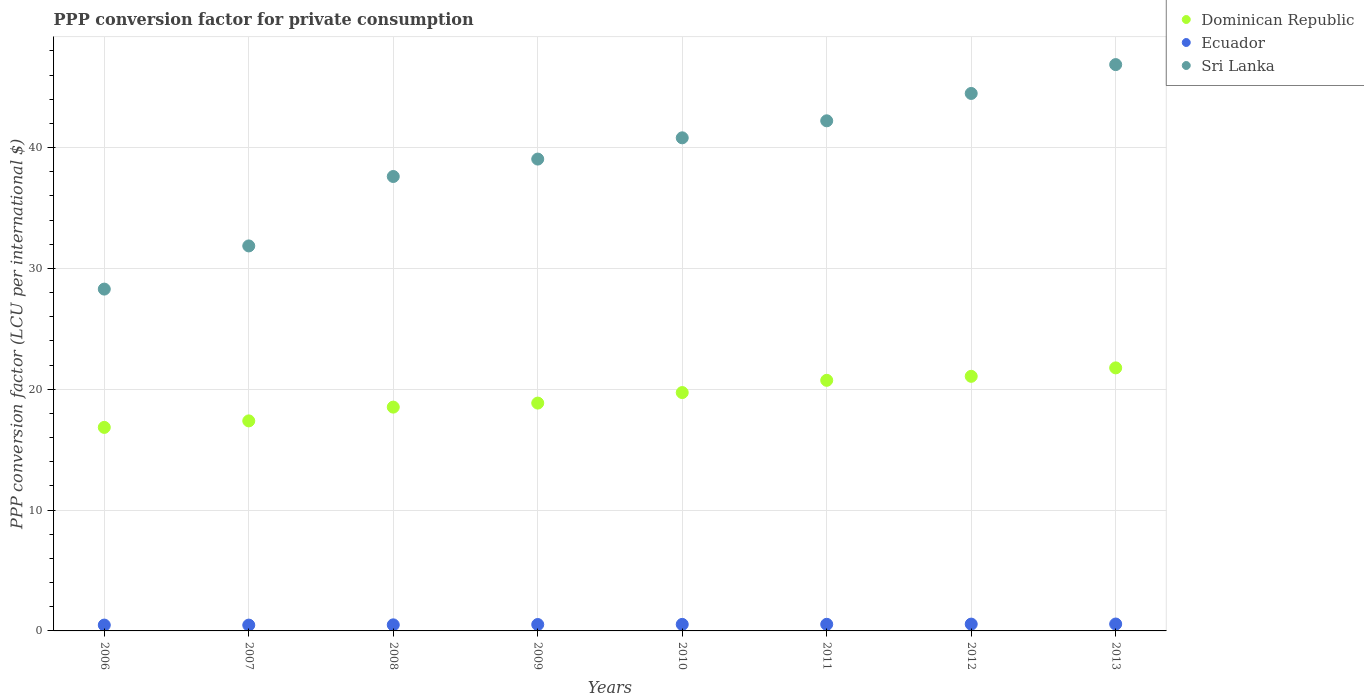How many different coloured dotlines are there?
Offer a terse response. 3. What is the PPP conversion factor for private consumption in Sri Lanka in 2013?
Your answer should be compact. 46.87. Across all years, what is the maximum PPP conversion factor for private consumption in Ecuador?
Make the answer very short. 0.57. Across all years, what is the minimum PPP conversion factor for private consumption in Ecuador?
Give a very brief answer. 0.48. In which year was the PPP conversion factor for private consumption in Sri Lanka maximum?
Your answer should be very brief. 2013. What is the total PPP conversion factor for private consumption in Ecuador in the graph?
Keep it short and to the point. 4.22. What is the difference between the PPP conversion factor for private consumption in Sri Lanka in 2006 and that in 2010?
Give a very brief answer. -12.52. What is the difference between the PPP conversion factor for private consumption in Dominican Republic in 2011 and the PPP conversion factor for private consumption in Sri Lanka in 2013?
Offer a very short reply. -26.13. What is the average PPP conversion factor for private consumption in Ecuador per year?
Keep it short and to the point. 0.53. In the year 2009, what is the difference between the PPP conversion factor for private consumption in Dominican Republic and PPP conversion factor for private consumption in Sri Lanka?
Keep it short and to the point. -20.2. In how many years, is the PPP conversion factor for private consumption in Dominican Republic greater than 32 LCU?
Your answer should be compact. 0. What is the ratio of the PPP conversion factor for private consumption in Sri Lanka in 2008 to that in 2012?
Ensure brevity in your answer.  0.85. Is the PPP conversion factor for private consumption in Dominican Republic in 2011 less than that in 2012?
Provide a succinct answer. Yes. What is the difference between the highest and the second highest PPP conversion factor for private consumption in Sri Lanka?
Your answer should be compact. 2.39. What is the difference between the highest and the lowest PPP conversion factor for private consumption in Sri Lanka?
Ensure brevity in your answer.  18.58. Does the PPP conversion factor for private consumption in Ecuador monotonically increase over the years?
Your response must be concise. No. What is the difference between two consecutive major ticks on the Y-axis?
Your answer should be very brief. 10. Are the values on the major ticks of Y-axis written in scientific E-notation?
Provide a succinct answer. No. Does the graph contain any zero values?
Make the answer very short. No. Where does the legend appear in the graph?
Ensure brevity in your answer.  Top right. How are the legend labels stacked?
Provide a short and direct response. Vertical. What is the title of the graph?
Your response must be concise. PPP conversion factor for private consumption. Does "Low & middle income" appear as one of the legend labels in the graph?
Offer a very short reply. No. What is the label or title of the X-axis?
Make the answer very short. Years. What is the label or title of the Y-axis?
Ensure brevity in your answer.  PPP conversion factor (LCU per international $). What is the PPP conversion factor (LCU per international $) in Dominican Republic in 2006?
Your answer should be compact. 16.84. What is the PPP conversion factor (LCU per international $) of Ecuador in 2006?
Give a very brief answer. 0.48. What is the PPP conversion factor (LCU per international $) of Sri Lanka in 2006?
Give a very brief answer. 28.29. What is the PPP conversion factor (LCU per international $) in Dominican Republic in 2007?
Offer a very short reply. 17.38. What is the PPP conversion factor (LCU per international $) of Ecuador in 2007?
Offer a very short reply. 0.48. What is the PPP conversion factor (LCU per international $) in Sri Lanka in 2007?
Provide a succinct answer. 31.86. What is the PPP conversion factor (LCU per international $) in Dominican Republic in 2008?
Make the answer very short. 18.52. What is the PPP conversion factor (LCU per international $) of Ecuador in 2008?
Offer a very short reply. 0.5. What is the PPP conversion factor (LCU per international $) in Sri Lanka in 2008?
Offer a very short reply. 37.61. What is the PPP conversion factor (LCU per international $) of Dominican Republic in 2009?
Your answer should be very brief. 18.86. What is the PPP conversion factor (LCU per international $) in Ecuador in 2009?
Keep it short and to the point. 0.53. What is the PPP conversion factor (LCU per international $) in Sri Lanka in 2009?
Your response must be concise. 39.05. What is the PPP conversion factor (LCU per international $) of Dominican Republic in 2010?
Your response must be concise. 19.73. What is the PPP conversion factor (LCU per international $) of Ecuador in 2010?
Your answer should be very brief. 0.54. What is the PPP conversion factor (LCU per international $) in Sri Lanka in 2010?
Provide a short and direct response. 40.81. What is the PPP conversion factor (LCU per international $) of Dominican Republic in 2011?
Keep it short and to the point. 20.74. What is the PPP conversion factor (LCU per international $) of Ecuador in 2011?
Give a very brief answer. 0.55. What is the PPP conversion factor (LCU per international $) of Sri Lanka in 2011?
Offer a very short reply. 42.22. What is the PPP conversion factor (LCU per international $) in Dominican Republic in 2012?
Give a very brief answer. 21.07. What is the PPP conversion factor (LCU per international $) in Ecuador in 2012?
Your response must be concise. 0.56. What is the PPP conversion factor (LCU per international $) of Sri Lanka in 2012?
Ensure brevity in your answer.  44.48. What is the PPP conversion factor (LCU per international $) of Dominican Republic in 2013?
Provide a succinct answer. 21.77. What is the PPP conversion factor (LCU per international $) in Ecuador in 2013?
Your answer should be very brief. 0.57. What is the PPP conversion factor (LCU per international $) of Sri Lanka in 2013?
Keep it short and to the point. 46.87. Across all years, what is the maximum PPP conversion factor (LCU per international $) in Dominican Republic?
Your answer should be very brief. 21.77. Across all years, what is the maximum PPP conversion factor (LCU per international $) of Ecuador?
Give a very brief answer. 0.57. Across all years, what is the maximum PPP conversion factor (LCU per international $) of Sri Lanka?
Ensure brevity in your answer.  46.87. Across all years, what is the minimum PPP conversion factor (LCU per international $) of Dominican Republic?
Offer a terse response. 16.84. Across all years, what is the minimum PPP conversion factor (LCU per international $) in Ecuador?
Offer a terse response. 0.48. Across all years, what is the minimum PPP conversion factor (LCU per international $) in Sri Lanka?
Give a very brief answer. 28.29. What is the total PPP conversion factor (LCU per international $) of Dominican Republic in the graph?
Provide a short and direct response. 154.92. What is the total PPP conversion factor (LCU per international $) in Ecuador in the graph?
Your answer should be very brief. 4.22. What is the total PPP conversion factor (LCU per international $) of Sri Lanka in the graph?
Your response must be concise. 311.2. What is the difference between the PPP conversion factor (LCU per international $) of Dominican Republic in 2006 and that in 2007?
Provide a succinct answer. -0.54. What is the difference between the PPP conversion factor (LCU per international $) in Ecuador in 2006 and that in 2007?
Provide a short and direct response. 0. What is the difference between the PPP conversion factor (LCU per international $) in Sri Lanka in 2006 and that in 2007?
Your response must be concise. -3.57. What is the difference between the PPP conversion factor (LCU per international $) of Dominican Republic in 2006 and that in 2008?
Offer a very short reply. -1.68. What is the difference between the PPP conversion factor (LCU per international $) of Ecuador in 2006 and that in 2008?
Your answer should be compact. -0.02. What is the difference between the PPP conversion factor (LCU per international $) in Sri Lanka in 2006 and that in 2008?
Keep it short and to the point. -9.32. What is the difference between the PPP conversion factor (LCU per international $) of Dominican Republic in 2006 and that in 2009?
Give a very brief answer. -2.01. What is the difference between the PPP conversion factor (LCU per international $) of Ecuador in 2006 and that in 2009?
Offer a very short reply. -0.05. What is the difference between the PPP conversion factor (LCU per international $) of Sri Lanka in 2006 and that in 2009?
Provide a succinct answer. -10.76. What is the difference between the PPP conversion factor (LCU per international $) of Dominican Republic in 2006 and that in 2010?
Give a very brief answer. -2.88. What is the difference between the PPP conversion factor (LCU per international $) in Ecuador in 2006 and that in 2010?
Your answer should be compact. -0.06. What is the difference between the PPP conversion factor (LCU per international $) of Sri Lanka in 2006 and that in 2010?
Your answer should be very brief. -12.52. What is the difference between the PPP conversion factor (LCU per international $) of Dominican Republic in 2006 and that in 2011?
Make the answer very short. -3.9. What is the difference between the PPP conversion factor (LCU per international $) of Ecuador in 2006 and that in 2011?
Provide a short and direct response. -0.06. What is the difference between the PPP conversion factor (LCU per international $) of Sri Lanka in 2006 and that in 2011?
Your answer should be compact. -13.93. What is the difference between the PPP conversion factor (LCU per international $) in Dominican Republic in 2006 and that in 2012?
Provide a short and direct response. -4.23. What is the difference between the PPP conversion factor (LCU per international $) in Ecuador in 2006 and that in 2012?
Provide a short and direct response. -0.08. What is the difference between the PPP conversion factor (LCU per international $) in Sri Lanka in 2006 and that in 2012?
Ensure brevity in your answer.  -16.19. What is the difference between the PPP conversion factor (LCU per international $) in Dominican Republic in 2006 and that in 2013?
Offer a very short reply. -4.93. What is the difference between the PPP conversion factor (LCU per international $) of Ecuador in 2006 and that in 2013?
Offer a very short reply. -0.09. What is the difference between the PPP conversion factor (LCU per international $) of Sri Lanka in 2006 and that in 2013?
Your response must be concise. -18.58. What is the difference between the PPP conversion factor (LCU per international $) in Dominican Republic in 2007 and that in 2008?
Give a very brief answer. -1.14. What is the difference between the PPP conversion factor (LCU per international $) of Ecuador in 2007 and that in 2008?
Offer a terse response. -0.02. What is the difference between the PPP conversion factor (LCU per international $) of Sri Lanka in 2007 and that in 2008?
Keep it short and to the point. -5.75. What is the difference between the PPP conversion factor (LCU per international $) of Dominican Republic in 2007 and that in 2009?
Your answer should be very brief. -1.47. What is the difference between the PPP conversion factor (LCU per international $) of Ecuador in 2007 and that in 2009?
Keep it short and to the point. -0.05. What is the difference between the PPP conversion factor (LCU per international $) of Sri Lanka in 2007 and that in 2009?
Your answer should be very brief. -7.19. What is the difference between the PPP conversion factor (LCU per international $) of Dominican Republic in 2007 and that in 2010?
Your answer should be compact. -2.34. What is the difference between the PPP conversion factor (LCU per international $) in Ecuador in 2007 and that in 2010?
Your answer should be compact. -0.06. What is the difference between the PPP conversion factor (LCU per international $) in Sri Lanka in 2007 and that in 2010?
Provide a short and direct response. -8.95. What is the difference between the PPP conversion factor (LCU per international $) in Dominican Republic in 2007 and that in 2011?
Offer a terse response. -3.36. What is the difference between the PPP conversion factor (LCU per international $) of Ecuador in 2007 and that in 2011?
Keep it short and to the point. -0.07. What is the difference between the PPP conversion factor (LCU per international $) in Sri Lanka in 2007 and that in 2011?
Provide a short and direct response. -10.36. What is the difference between the PPP conversion factor (LCU per international $) in Dominican Republic in 2007 and that in 2012?
Make the answer very short. -3.69. What is the difference between the PPP conversion factor (LCU per international $) of Ecuador in 2007 and that in 2012?
Keep it short and to the point. -0.08. What is the difference between the PPP conversion factor (LCU per international $) of Sri Lanka in 2007 and that in 2012?
Your answer should be very brief. -12.62. What is the difference between the PPP conversion factor (LCU per international $) of Dominican Republic in 2007 and that in 2013?
Ensure brevity in your answer.  -4.39. What is the difference between the PPP conversion factor (LCU per international $) in Ecuador in 2007 and that in 2013?
Keep it short and to the point. -0.09. What is the difference between the PPP conversion factor (LCU per international $) in Sri Lanka in 2007 and that in 2013?
Provide a succinct answer. -15.01. What is the difference between the PPP conversion factor (LCU per international $) of Dominican Republic in 2008 and that in 2009?
Your response must be concise. -0.33. What is the difference between the PPP conversion factor (LCU per international $) in Ecuador in 2008 and that in 2009?
Make the answer very short. -0.03. What is the difference between the PPP conversion factor (LCU per international $) of Sri Lanka in 2008 and that in 2009?
Offer a very short reply. -1.44. What is the difference between the PPP conversion factor (LCU per international $) of Dominican Republic in 2008 and that in 2010?
Your response must be concise. -1.2. What is the difference between the PPP conversion factor (LCU per international $) in Ecuador in 2008 and that in 2010?
Provide a short and direct response. -0.04. What is the difference between the PPP conversion factor (LCU per international $) of Sri Lanka in 2008 and that in 2010?
Provide a short and direct response. -3.2. What is the difference between the PPP conversion factor (LCU per international $) in Dominican Republic in 2008 and that in 2011?
Offer a very short reply. -2.22. What is the difference between the PPP conversion factor (LCU per international $) in Ecuador in 2008 and that in 2011?
Your answer should be very brief. -0.04. What is the difference between the PPP conversion factor (LCU per international $) of Sri Lanka in 2008 and that in 2011?
Offer a very short reply. -4.61. What is the difference between the PPP conversion factor (LCU per international $) of Dominican Republic in 2008 and that in 2012?
Provide a succinct answer. -2.55. What is the difference between the PPP conversion factor (LCU per international $) of Ecuador in 2008 and that in 2012?
Provide a succinct answer. -0.06. What is the difference between the PPP conversion factor (LCU per international $) in Sri Lanka in 2008 and that in 2012?
Your answer should be very brief. -6.87. What is the difference between the PPP conversion factor (LCU per international $) of Dominican Republic in 2008 and that in 2013?
Your response must be concise. -3.25. What is the difference between the PPP conversion factor (LCU per international $) in Ecuador in 2008 and that in 2013?
Offer a very short reply. -0.07. What is the difference between the PPP conversion factor (LCU per international $) in Sri Lanka in 2008 and that in 2013?
Your answer should be compact. -9.26. What is the difference between the PPP conversion factor (LCU per international $) of Dominican Republic in 2009 and that in 2010?
Provide a short and direct response. -0.87. What is the difference between the PPP conversion factor (LCU per international $) in Ecuador in 2009 and that in 2010?
Your answer should be compact. -0.01. What is the difference between the PPP conversion factor (LCU per international $) of Sri Lanka in 2009 and that in 2010?
Offer a terse response. -1.76. What is the difference between the PPP conversion factor (LCU per international $) in Dominican Republic in 2009 and that in 2011?
Provide a short and direct response. -1.88. What is the difference between the PPP conversion factor (LCU per international $) of Ecuador in 2009 and that in 2011?
Provide a short and direct response. -0.02. What is the difference between the PPP conversion factor (LCU per international $) of Sri Lanka in 2009 and that in 2011?
Offer a very short reply. -3.17. What is the difference between the PPP conversion factor (LCU per international $) in Dominican Republic in 2009 and that in 2012?
Provide a succinct answer. -2.21. What is the difference between the PPP conversion factor (LCU per international $) in Ecuador in 2009 and that in 2012?
Ensure brevity in your answer.  -0.03. What is the difference between the PPP conversion factor (LCU per international $) of Sri Lanka in 2009 and that in 2012?
Ensure brevity in your answer.  -5.43. What is the difference between the PPP conversion factor (LCU per international $) of Dominican Republic in 2009 and that in 2013?
Keep it short and to the point. -2.91. What is the difference between the PPP conversion factor (LCU per international $) of Ecuador in 2009 and that in 2013?
Keep it short and to the point. -0.04. What is the difference between the PPP conversion factor (LCU per international $) of Sri Lanka in 2009 and that in 2013?
Your answer should be compact. -7.82. What is the difference between the PPP conversion factor (LCU per international $) in Dominican Republic in 2010 and that in 2011?
Ensure brevity in your answer.  -1.01. What is the difference between the PPP conversion factor (LCU per international $) of Ecuador in 2010 and that in 2011?
Provide a short and direct response. -0.01. What is the difference between the PPP conversion factor (LCU per international $) in Sri Lanka in 2010 and that in 2011?
Make the answer very short. -1.41. What is the difference between the PPP conversion factor (LCU per international $) in Dominican Republic in 2010 and that in 2012?
Ensure brevity in your answer.  -1.34. What is the difference between the PPP conversion factor (LCU per international $) of Ecuador in 2010 and that in 2012?
Your answer should be very brief. -0.02. What is the difference between the PPP conversion factor (LCU per international $) of Sri Lanka in 2010 and that in 2012?
Provide a short and direct response. -3.67. What is the difference between the PPP conversion factor (LCU per international $) in Dominican Republic in 2010 and that in 2013?
Provide a succinct answer. -2.04. What is the difference between the PPP conversion factor (LCU per international $) of Ecuador in 2010 and that in 2013?
Your response must be concise. -0.03. What is the difference between the PPP conversion factor (LCU per international $) of Sri Lanka in 2010 and that in 2013?
Ensure brevity in your answer.  -6.06. What is the difference between the PPP conversion factor (LCU per international $) of Dominican Republic in 2011 and that in 2012?
Offer a terse response. -0.33. What is the difference between the PPP conversion factor (LCU per international $) of Ecuador in 2011 and that in 2012?
Give a very brief answer. -0.02. What is the difference between the PPP conversion factor (LCU per international $) in Sri Lanka in 2011 and that in 2012?
Your answer should be very brief. -2.26. What is the difference between the PPP conversion factor (LCU per international $) in Dominican Republic in 2011 and that in 2013?
Your response must be concise. -1.03. What is the difference between the PPP conversion factor (LCU per international $) in Ecuador in 2011 and that in 2013?
Make the answer very short. -0.02. What is the difference between the PPP conversion factor (LCU per international $) in Sri Lanka in 2011 and that in 2013?
Your answer should be very brief. -4.65. What is the difference between the PPP conversion factor (LCU per international $) of Dominican Republic in 2012 and that in 2013?
Ensure brevity in your answer.  -0.7. What is the difference between the PPP conversion factor (LCU per international $) in Ecuador in 2012 and that in 2013?
Provide a short and direct response. -0.01. What is the difference between the PPP conversion factor (LCU per international $) of Sri Lanka in 2012 and that in 2013?
Give a very brief answer. -2.39. What is the difference between the PPP conversion factor (LCU per international $) of Dominican Republic in 2006 and the PPP conversion factor (LCU per international $) of Ecuador in 2007?
Keep it short and to the point. 16.36. What is the difference between the PPP conversion factor (LCU per international $) in Dominican Republic in 2006 and the PPP conversion factor (LCU per international $) in Sri Lanka in 2007?
Your answer should be very brief. -15.02. What is the difference between the PPP conversion factor (LCU per international $) of Ecuador in 2006 and the PPP conversion factor (LCU per international $) of Sri Lanka in 2007?
Ensure brevity in your answer.  -31.38. What is the difference between the PPP conversion factor (LCU per international $) of Dominican Republic in 2006 and the PPP conversion factor (LCU per international $) of Ecuador in 2008?
Offer a very short reply. 16.34. What is the difference between the PPP conversion factor (LCU per international $) of Dominican Republic in 2006 and the PPP conversion factor (LCU per international $) of Sri Lanka in 2008?
Offer a very short reply. -20.77. What is the difference between the PPP conversion factor (LCU per international $) of Ecuador in 2006 and the PPP conversion factor (LCU per international $) of Sri Lanka in 2008?
Provide a short and direct response. -37.13. What is the difference between the PPP conversion factor (LCU per international $) of Dominican Republic in 2006 and the PPP conversion factor (LCU per international $) of Ecuador in 2009?
Give a very brief answer. 16.31. What is the difference between the PPP conversion factor (LCU per international $) in Dominican Republic in 2006 and the PPP conversion factor (LCU per international $) in Sri Lanka in 2009?
Provide a succinct answer. -22.21. What is the difference between the PPP conversion factor (LCU per international $) of Ecuador in 2006 and the PPP conversion factor (LCU per international $) of Sri Lanka in 2009?
Give a very brief answer. -38.57. What is the difference between the PPP conversion factor (LCU per international $) of Dominican Republic in 2006 and the PPP conversion factor (LCU per international $) of Ecuador in 2010?
Offer a very short reply. 16.3. What is the difference between the PPP conversion factor (LCU per international $) of Dominican Republic in 2006 and the PPP conversion factor (LCU per international $) of Sri Lanka in 2010?
Your answer should be compact. -23.97. What is the difference between the PPP conversion factor (LCU per international $) in Ecuador in 2006 and the PPP conversion factor (LCU per international $) in Sri Lanka in 2010?
Provide a succinct answer. -40.33. What is the difference between the PPP conversion factor (LCU per international $) of Dominican Republic in 2006 and the PPP conversion factor (LCU per international $) of Ecuador in 2011?
Offer a very short reply. 16.3. What is the difference between the PPP conversion factor (LCU per international $) in Dominican Republic in 2006 and the PPP conversion factor (LCU per international $) in Sri Lanka in 2011?
Provide a short and direct response. -25.37. What is the difference between the PPP conversion factor (LCU per international $) in Ecuador in 2006 and the PPP conversion factor (LCU per international $) in Sri Lanka in 2011?
Make the answer very short. -41.73. What is the difference between the PPP conversion factor (LCU per international $) of Dominican Republic in 2006 and the PPP conversion factor (LCU per international $) of Ecuador in 2012?
Provide a succinct answer. 16.28. What is the difference between the PPP conversion factor (LCU per international $) of Dominican Republic in 2006 and the PPP conversion factor (LCU per international $) of Sri Lanka in 2012?
Offer a terse response. -27.64. What is the difference between the PPP conversion factor (LCU per international $) of Ecuador in 2006 and the PPP conversion factor (LCU per international $) of Sri Lanka in 2012?
Provide a short and direct response. -44. What is the difference between the PPP conversion factor (LCU per international $) in Dominican Republic in 2006 and the PPP conversion factor (LCU per international $) in Ecuador in 2013?
Provide a succinct answer. 16.27. What is the difference between the PPP conversion factor (LCU per international $) of Dominican Republic in 2006 and the PPP conversion factor (LCU per international $) of Sri Lanka in 2013?
Your response must be concise. -30.03. What is the difference between the PPP conversion factor (LCU per international $) of Ecuador in 2006 and the PPP conversion factor (LCU per international $) of Sri Lanka in 2013?
Your answer should be very brief. -46.39. What is the difference between the PPP conversion factor (LCU per international $) of Dominican Republic in 2007 and the PPP conversion factor (LCU per international $) of Ecuador in 2008?
Give a very brief answer. 16.88. What is the difference between the PPP conversion factor (LCU per international $) of Dominican Republic in 2007 and the PPP conversion factor (LCU per international $) of Sri Lanka in 2008?
Ensure brevity in your answer.  -20.23. What is the difference between the PPP conversion factor (LCU per international $) of Ecuador in 2007 and the PPP conversion factor (LCU per international $) of Sri Lanka in 2008?
Your answer should be very brief. -37.13. What is the difference between the PPP conversion factor (LCU per international $) in Dominican Republic in 2007 and the PPP conversion factor (LCU per international $) in Ecuador in 2009?
Ensure brevity in your answer.  16.85. What is the difference between the PPP conversion factor (LCU per international $) of Dominican Republic in 2007 and the PPP conversion factor (LCU per international $) of Sri Lanka in 2009?
Your answer should be very brief. -21.67. What is the difference between the PPP conversion factor (LCU per international $) in Ecuador in 2007 and the PPP conversion factor (LCU per international $) in Sri Lanka in 2009?
Ensure brevity in your answer.  -38.57. What is the difference between the PPP conversion factor (LCU per international $) of Dominican Republic in 2007 and the PPP conversion factor (LCU per international $) of Ecuador in 2010?
Offer a very short reply. 16.84. What is the difference between the PPP conversion factor (LCU per international $) in Dominican Republic in 2007 and the PPP conversion factor (LCU per international $) in Sri Lanka in 2010?
Your answer should be very brief. -23.43. What is the difference between the PPP conversion factor (LCU per international $) of Ecuador in 2007 and the PPP conversion factor (LCU per international $) of Sri Lanka in 2010?
Make the answer very short. -40.33. What is the difference between the PPP conversion factor (LCU per international $) of Dominican Republic in 2007 and the PPP conversion factor (LCU per international $) of Ecuador in 2011?
Offer a terse response. 16.84. What is the difference between the PPP conversion factor (LCU per international $) in Dominican Republic in 2007 and the PPP conversion factor (LCU per international $) in Sri Lanka in 2011?
Give a very brief answer. -24.84. What is the difference between the PPP conversion factor (LCU per international $) of Ecuador in 2007 and the PPP conversion factor (LCU per international $) of Sri Lanka in 2011?
Offer a very short reply. -41.74. What is the difference between the PPP conversion factor (LCU per international $) in Dominican Republic in 2007 and the PPP conversion factor (LCU per international $) in Ecuador in 2012?
Make the answer very short. 16.82. What is the difference between the PPP conversion factor (LCU per international $) in Dominican Republic in 2007 and the PPP conversion factor (LCU per international $) in Sri Lanka in 2012?
Ensure brevity in your answer.  -27.1. What is the difference between the PPP conversion factor (LCU per international $) of Ecuador in 2007 and the PPP conversion factor (LCU per international $) of Sri Lanka in 2012?
Keep it short and to the point. -44. What is the difference between the PPP conversion factor (LCU per international $) in Dominican Republic in 2007 and the PPP conversion factor (LCU per international $) in Ecuador in 2013?
Offer a very short reply. 16.81. What is the difference between the PPP conversion factor (LCU per international $) of Dominican Republic in 2007 and the PPP conversion factor (LCU per international $) of Sri Lanka in 2013?
Your answer should be very brief. -29.49. What is the difference between the PPP conversion factor (LCU per international $) of Ecuador in 2007 and the PPP conversion factor (LCU per international $) of Sri Lanka in 2013?
Your response must be concise. -46.39. What is the difference between the PPP conversion factor (LCU per international $) in Dominican Republic in 2008 and the PPP conversion factor (LCU per international $) in Ecuador in 2009?
Offer a terse response. 17.99. What is the difference between the PPP conversion factor (LCU per international $) in Dominican Republic in 2008 and the PPP conversion factor (LCU per international $) in Sri Lanka in 2009?
Ensure brevity in your answer.  -20.53. What is the difference between the PPP conversion factor (LCU per international $) in Ecuador in 2008 and the PPP conversion factor (LCU per international $) in Sri Lanka in 2009?
Ensure brevity in your answer.  -38.55. What is the difference between the PPP conversion factor (LCU per international $) in Dominican Republic in 2008 and the PPP conversion factor (LCU per international $) in Ecuador in 2010?
Offer a terse response. 17.98. What is the difference between the PPP conversion factor (LCU per international $) in Dominican Republic in 2008 and the PPP conversion factor (LCU per international $) in Sri Lanka in 2010?
Offer a terse response. -22.29. What is the difference between the PPP conversion factor (LCU per international $) of Ecuador in 2008 and the PPP conversion factor (LCU per international $) of Sri Lanka in 2010?
Your answer should be very brief. -40.31. What is the difference between the PPP conversion factor (LCU per international $) of Dominican Republic in 2008 and the PPP conversion factor (LCU per international $) of Ecuador in 2011?
Your answer should be very brief. 17.98. What is the difference between the PPP conversion factor (LCU per international $) in Dominican Republic in 2008 and the PPP conversion factor (LCU per international $) in Sri Lanka in 2011?
Provide a succinct answer. -23.7. What is the difference between the PPP conversion factor (LCU per international $) in Ecuador in 2008 and the PPP conversion factor (LCU per international $) in Sri Lanka in 2011?
Ensure brevity in your answer.  -41.72. What is the difference between the PPP conversion factor (LCU per international $) in Dominican Republic in 2008 and the PPP conversion factor (LCU per international $) in Ecuador in 2012?
Your response must be concise. 17.96. What is the difference between the PPP conversion factor (LCU per international $) in Dominican Republic in 2008 and the PPP conversion factor (LCU per international $) in Sri Lanka in 2012?
Ensure brevity in your answer.  -25.96. What is the difference between the PPP conversion factor (LCU per international $) in Ecuador in 2008 and the PPP conversion factor (LCU per international $) in Sri Lanka in 2012?
Keep it short and to the point. -43.98. What is the difference between the PPP conversion factor (LCU per international $) of Dominican Republic in 2008 and the PPP conversion factor (LCU per international $) of Ecuador in 2013?
Your answer should be compact. 17.95. What is the difference between the PPP conversion factor (LCU per international $) in Dominican Republic in 2008 and the PPP conversion factor (LCU per international $) in Sri Lanka in 2013?
Give a very brief answer. -28.35. What is the difference between the PPP conversion factor (LCU per international $) in Ecuador in 2008 and the PPP conversion factor (LCU per international $) in Sri Lanka in 2013?
Provide a succinct answer. -46.37. What is the difference between the PPP conversion factor (LCU per international $) in Dominican Republic in 2009 and the PPP conversion factor (LCU per international $) in Ecuador in 2010?
Ensure brevity in your answer.  18.32. What is the difference between the PPP conversion factor (LCU per international $) of Dominican Republic in 2009 and the PPP conversion factor (LCU per international $) of Sri Lanka in 2010?
Offer a terse response. -21.95. What is the difference between the PPP conversion factor (LCU per international $) of Ecuador in 2009 and the PPP conversion factor (LCU per international $) of Sri Lanka in 2010?
Provide a short and direct response. -40.28. What is the difference between the PPP conversion factor (LCU per international $) of Dominican Republic in 2009 and the PPP conversion factor (LCU per international $) of Ecuador in 2011?
Your response must be concise. 18.31. What is the difference between the PPP conversion factor (LCU per international $) of Dominican Republic in 2009 and the PPP conversion factor (LCU per international $) of Sri Lanka in 2011?
Make the answer very short. -23.36. What is the difference between the PPP conversion factor (LCU per international $) of Ecuador in 2009 and the PPP conversion factor (LCU per international $) of Sri Lanka in 2011?
Give a very brief answer. -41.69. What is the difference between the PPP conversion factor (LCU per international $) in Dominican Republic in 2009 and the PPP conversion factor (LCU per international $) in Ecuador in 2012?
Give a very brief answer. 18.29. What is the difference between the PPP conversion factor (LCU per international $) of Dominican Republic in 2009 and the PPP conversion factor (LCU per international $) of Sri Lanka in 2012?
Offer a very short reply. -25.63. What is the difference between the PPP conversion factor (LCU per international $) in Ecuador in 2009 and the PPP conversion factor (LCU per international $) in Sri Lanka in 2012?
Ensure brevity in your answer.  -43.95. What is the difference between the PPP conversion factor (LCU per international $) in Dominican Republic in 2009 and the PPP conversion factor (LCU per international $) in Ecuador in 2013?
Provide a succinct answer. 18.29. What is the difference between the PPP conversion factor (LCU per international $) in Dominican Republic in 2009 and the PPP conversion factor (LCU per international $) in Sri Lanka in 2013?
Offer a terse response. -28.01. What is the difference between the PPP conversion factor (LCU per international $) of Ecuador in 2009 and the PPP conversion factor (LCU per international $) of Sri Lanka in 2013?
Offer a very short reply. -46.34. What is the difference between the PPP conversion factor (LCU per international $) in Dominican Republic in 2010 and the PPP conversion factor (LCU per international $) in Ecuador in 2011?
Ensure brevity in your answer.  19.18. What is the difference between the PPP conversion factor (LCU per international $) in Dominican Republic in 2010 and the PPP conversion factor (LCU per international $) in Sri Lanka in 2011?
Provide a short and direct response. -22.49. What is the difference between the PPP conversion factor (LCU per international $) in Ecuador in 2010 and the PPP conversion factor (LCU per international $) in Sri Lanka in 2011?
Make the answer very short. -41.68. What is the difference between the PPP conversion factor (LCU per international $) in Dominican Republic in 2010 and the PPP conversion factor (LCU per international $) in Ecuador in 2012?
Your response must be concise. 19.16. What is the difference between the PPP conversion factor (LCU per international $) in Dominican Republic in 2010 and the PPP conversion factor (LCU per international $) in Sri Lanka in 2012?
Provide a succinct answer. -24.76. What is the difference between the PPP conversion factor (LCU per international $) of Ecuador in 2010 and the PPP conversion factor (LCU per international $) of Sri Lanka in 2012?
Keep it short and to the point. -43.94. What is the difference between the PPP conversion factor (LCU per international $) of Dominican Republic in 2010 and the PPP conversion factor (LCU per international $) of Ecuador in 2013?
Your answer should be compact. 19.16. What is the difference between the PPP conversion factor (LCU per international $) in Dominican Republic in 2010 and the PPP conversion factor (LCU per international $) in Sri Lanka in 2013?
Your response must be concise. -27.14. What is the difference between the PPP conversion factor (LCU per international $) of Ecuador in 2010 and the PPP conversion factor (LCU per international $) of Sri Lanka in 2013?
Give a very brief answer. -46.33. What is the difference between the PPP conversion factor (LCU per international $) in Dominican Republic in 2011 and the PPP conversion factor (LCU per international $) in Ecuador in 2012?
Offer a terse response. 20.18. What is the difference between the PPP conversion factor (LCU per international $) of Dominican Republic in 2011 and the PPP conversion factor (LCU per international $) of Sri Lanka in 2012?
Keep it short and to the point. -23.74. What is the difference between the PPP conversion factor (LCU per international $) in Ecuador in 2011 and the PPP conversion factor (LCU per international $) in Sri Lanka in 2012?
Offer a terse response. -43.94. What is the difference between the PPP conversion factor (LCU per international $) in Dominican Republic in 2011 and the PPP conversion factor (LCU per international $) in Ecuador in 2013?
Your response must be concise. 20.17. What is the difference between the PPP conversion factor (LCU per international $) in Dominican Republic in 2011 and the PPP conversion factor (LCU per international $) in Sri Lanka in 2013?
Offer a very short reply. -26.13. What is the difference between the PPP conversion factor (LCU per international $) of Ecuador in 2011 and the PPP conversion factor (LCU per international $) of Sri Lanka in 2013?
Keep it short and to the point. -46.32. What is the difference between the PPP conversion factor (LCU per international $) of Dominican Republic in 2012 and the PPP conversion factor (LCU per international $) of Ecuador in 2013?
Offer a terse response. 20.5. What is the difference between the PPP conversion factor (LCU per international $) of Dominican Republic in 2012 and the PPP conversion factor (LCU per international $) of Sri Lanka in 2013?
Provide a succinct answer. -25.8. What is the difference between the PPP conversion factor (LCU per international $) of Ecuador in 2012 and the PPP conversion factor (LCU per international $) of Sri Lanka in 2013?
Offer a very short reply. -46.31. What is the average PPP conversion factor (LCU per international $) in Dominican Republic per year?
Ensure brevity in your answer.  19.36. What is the average PPP conversion factor (LCU per international $) of Ecuador per year?
Provide a short and direct response. 0.53. What is the average PPP conversion factor (LCU per international $) in Sri Lanka per year?
Your answer should be compact. 38.9. In the year 2006, what is the difference between the PPP conversion factor (LCU per international $) in Dominican Republic and PPP conversion factor (LCU per international $) in Ecuador?
Keep it short and to the point. 16.36. In the year 2006, what is the difference between the PPP conversion factor (LCU per international $) of Dominican Republic and PPP conversion factor (LCU per international $) of Sri Lanka?
Give a very brief answer. -11.45. In the year 2006, what is the difference between the PPP conversion factor (LCU per international $) of Ecuador and PPP conversion factor (LCU per international $) of Sri Lanka?
Provide a short and direct response. -27.81. In the year 2007, what is the difference between the PPP conversion factor (LCU per international $) of Dominican Republic and PPP conversion factor (LCU per international $) of Ecuador?
Your response must be concise. 16.9. In the year 2007, what is the difference between the PPP conversion factor (LCU per international $) in Dominican Republic and PPP conversion factor (LCU per international $) in Sri Lanka?
Your response must be concise. -14.48. In the year 2007, what is the difference between the PPP conversion factor (LCU per international $) of Ecuador and PPP conversion factor (LCU per international $) of Sri Lanka?
Offer a very short reply. -31.38. In the year 2008, what is the difference between the PPP conversion factor (LCU per international $) of Dominican Republic and PPP conversion factor (LCU per international $) of Ecuador?
Ensure brevity in your answer.  18.02. In the year 2008, what is the difference between the PPP conversion factor (LCU per international $) of Dominican Republic and PPP conversion factor (LCU per international $) of Sri Lanka?
Keep it short and to the point. -19.09. In the year 2008, what is the difference between the PPP conversion factor (LCU per international $) in Ecuador and PPP conversion factor (LCU per international $) in Sri Lanka?
Your response must be concise. -37.11. In the year 2009, what is the difference between the PPP conversion factor (LCU per international $) of Dominican Republic and PPP conversion factor (LCU per international $) of Ecuador?
Ensure brevity in your answer.  18.33. In the year 2009, what is the difference between the PPP conversion factor (LCU per international $) in Dominican Republic and PPP conversion factor (LCU per international $) in Sri Lanka?
Offer a very short reply. -20.2. In the year 2009, what is the difference between the PPP conversion factor (LCU per international $) of Ecuador and PPP conversion factor (LCU per international $) of Sri Lanka?
Ensure brevity in your answer.  -38.52. In the year 2010, what is the difference between the PPP conversion factor (LCU per international $) of Dominican Republic and PPP conversion factor (LCU per international $) of Ecuador?
Provide a short and direct response. 19.19. In the year 2010, what is the difference between the PPP conversion factor (LCU per international $) of Dominican Republic and PPP conversion factor (LCU per international $) of Sri Lanka?
Your answer should be compact. -21.08. In the year 2010, what is the difference between the PPP conversion factor (LCU per international $) of Ecuador and PPP conversion factor (LCU per international $) of Sri Lanka?
Keep it short and to the point. -40.27. In the year 2011, what is the difference between the PPP conversion factor (LCU per international $) of Dominican Republic and PPP conversion factor (LCU per international $) of Ecuador?
Offer a very short reply. 20.19. In the year 2011, what is the difference between the PPP conversion factor (LCU per international $) in Dominican Republic and PPP conversion factor (LCU per international $) in Sri Lanka?
Your response must be concise. -21.48. In the year 2011, what is the difference between the PPP conversion factor (LCU per international $) in Ecuador and PPP conversion factor (LCU per international $) in Sri Lanka?
Your response must be concise. -41.67. In the year 2012, what is the difference between the PPP conversion factor (LCU per international $) in Dominican Republic and PPP conversion factor (LCU per international $) in Ecuador?
Your response must be concise. 20.51. In the year 2012, what is the difference between the PPP conversion factor (LCU per international $) of Dominican Republic and PPP conversion factor (LCU per international $) of Sri Lanka?
Provide a succinct answer. -23.41. In the year 2012, what is the difference between the PPP conversion factor (LCU per international $) of Ecuador and PPP conversion factor (LCU per international $) of Sri Lanka?
Your answer should be compact. -43.92. In the year 2013, what is the difference between the PPP conversion factor (LCU per international $) in Dominican Republic and PPP conversion factor (LCU per international $) in Ecuador?
Offer a terse response. 21.2. In the year 2013, what is the difference between the PPP conversion factor (LCU per international $) in Dominican Republic and PPP conversion factor (LCU per international $) in Sri Lanka?
Give a very brief answer. -25.1. In the year 2013, what is the difference between the PPP conversion factor (LCU per international $) in Ecuador and PPP conversion factor (LCU per international $) in Sri Lanka?
Ensure brevity in your answer.  -46.3. What is the ratio of the PPP conversion factor (LCU per international $) of Ecuador in 2006 to that in 2007?
Provide a succinct answer. 1.01. What is the ratio of the PPP conversion factor (LCU per international $) in Sri Lanka in 2006 to that in 2007?
Provide a succinct answer. 0.89. What is the ratio of the PPP conversion factor (LCU per international $) of Dominican Republic in 2006 to that in 2008?
Provide a succinct answer. 0.91. What is the ratio of the PPP conversion factor (LCU per international $) of Ecuador in 2006 to that in 2008?
Keep it short and to the point. 0.96. What is the ratio of the PPP conversion factor (LCU per international $) of Sri Lanka in 2006 to that in 2008?
Your answer should be very brief. 0.75. What is the ratio of the PPP conversion factor (LCU per international $) in Dominican Republic in 2006 to that in 2009?
Offer a very short reply. 0.89. What is the ratio of the PPP conversion factor (LCU per international $) in Ecuador in 2006 to that in 2009?
Give a very brief answer. 0.91. What is the ratio of the PPP conversion factor (LCU per international $) in Sri Lanka in 2006 to that in 2009?
Give a very brief answer. 0.72. What is the ratio of the PPP conversion factor (LCU per international $) in Dominican Republic in 2006 to that in 2010?
Your answer should be very brief. 0.85. What is the ratio of the PPP conversion factor (LCU per international $) of Ecuador in 2006 to that in 2010?
Ensure brevity in your answer.  0.9. What is the ratio of the PPP conversion factor (LCU per international $) in Sri Lanka in 2006 to that in 2010?
Your answer should be very brief. 0.69. What is the ratio of the PPP conversion factor (LCU per international $) in Dominican Republic in 2006 to that in 2011?
Ensure brevity in your answer.  0.81. What is the ratio of the PPP conversion factor (LCU per international $) of Ecuador in 2006 to that in 2011?
Offer a terse response. 0.88. What is the ratio of the PPP conversion factor (LCU per international $) of Sri Lanka in 2006 to that in 2011?
Your answer should be compact. 0.67. What is the ratio of the PPP conversion factor (LCU per international $) in Dominican Republic in 2006 to that in 2012?
Your response must be concise. 0.8. What is the ratio of the PPP conversion factor (LCU per international $) in Ecuador in 2006 to that in 2012?
Your answer should be compact. 0.86. What is the ratio of the PPP conversion factor (LCU per international $) of Sri Lanka in 2006 to that in 2012?
Provide a short and direct response. 0.64. What is the ratio of the PPP conversion factor (LCU per international $) of Dominican Republic in 2006 to that in 2013?
Your answer should be very brief. 0.77. What is the ratio of the PPP conversion factor (LCU per international $) in Ecuador in 2006 to that in 2013?
Give a very brief answer. 0.85. What is the ratio of the PPP conversion factor (LCU per international $) in Sri Lanka in 2006 to that in 2013?
Keep it short and to the point. 0.6. What is the ratio of the PPP conversion factor (LCU per international $) in Dominican Republic in 2007 to that in 2008?
Keep it short and to the point. 0.94. What is the ratio of the PPP conversion factor (LCU per international $) in Ecuador in 2007 to that in 2008?
Ensure brevity in your answer.  0.96. What is the ratio of the PPP conversion factor (LCU per international $) of Sri Lanka in 2007 to that in 2008?
Your response must be concise. 0.85. What is the ratio of the PPP conversion factor (LCU per international $) in Dominican Republic in 2007 to that in 2009?
Give a very brief answer. 0.92. What is the ratio of the PPP conversion factor (LCU per international $) of Ecuador in 2007 to that in 2009?
Provide a succinct answer. 0.91. What is the ratio of the PPP conversion factor (LCU per international $) of Sri Lanka in 2007 to that in 2009?
Ensure brevity in your answer.  0.82. What is the ratio of the PPP conversion factor (LCU per international $) of Dominican Republic in 2007 to that in 2010?
Make the answer very short. 0.88. What is the ratio of the PPP conversion factor (LCU per international $) of Ecuador in 2007 to that in 2010?
Your answer should be compact. 0.89. What is the ratio of the PPP conversion factor (LCU per international $) in Sri Lanka in 2007 to that in 2010?
Provide a succinct answer. 0.78. What is the ratio of the PPP conversion factor (LCU per international $) of Dominican Republic in 2007 to that in 2011?
Give a very brief answer. 0.84. What is the ratio of the PPP conversion factor (LCU per international $) of Ecuador in 2007 to that in 2011?
Ensure brevity in your answer.  0.88. What is the ratio of the PPP conversion factor (LCU per international $) of Sri Lanka in 2007 to that in 2011?
Give a very brief answer. 0.75. What is the ratio of the PPP conversion factor (LCU per international $) in Dominican Republic in 2007 to that in 2012?
Provide a short and direct response. 0.82. What is the ratio of the PPP conversion factor (LCU per international $) of Ecuador in 2007 to that in 2012?
Provide a short and direct response. 0.85. What is the ratio of the PPP conversion factor (LCU per international $) of Sri Lanka in 2007 to that in 2012?
Your answer should be very brief. 0.72. What is the ratio of the PPP conversion factor (LCU per international $) in Dominican Republic in 2007 to that in 2013?
Keep it short and to the point. 0.8. What is the ratio of the PPP conversion factor (LCU per international $) of Ecuador in 2007 to that in 2013?
Keep it short and to the point. 0.84. What is the ratio of the PPP conversion factor (LCU per international $) in Sri Lanka in 2007 to that in 2013?
Give a very brief answer. 0.68. What is the ratio of the PPP conversion factor (LCU per international $) in Dominican Republic in 2008 to that in 2009?
Provide a short and direct response. 0.98. What is the ratio of the PPP conversion factor (LCU per international $) in Ecuador in 2008 to that in 2009?
Your answer should be very brief. 0.95. What is the ratio of the PPP conversion factor (LCU per international $) in Sri Lanka in 2008 to that in 2009?
Provide a short and direct response. 0.96. What is the ratio of the PPP conversion factor (LCU per international $) of Dominican Republic in 2008 to that in 2010?
Provide a short and direct response. 0.94. What is the ratio of the PPP conversion factor (LCU per international $) of Ecuador in 2008 to that in 2010?
Make the answer very short. 0.93. What is the ratio of the PPP conversion factor (LCU per international $) of Sri Lanka in 2008 to that in 2010?
Provide a succinct answer. 0.92. What is the ratio of the PPP conversion factor (LCU per international $) of Dominican Republic in 2008 to that in 2011?
Provide a short and direct response. 0.89. What is the ratio of the PPP conversion factor (LCU per international $) of Ecuador in 2008 to that in 2011?
Your response must be concise. 0.92. What is the ratio of the PPP conversion factor (LCU per international $) in Sri Lanka in 2008 to that in 2011?
Your answer should be compact. 0.89. What is the ratio of the PPP conversion factor (LCU per international $) of Dominican Republic in 2008 to that in 2012?
Provide a short and direct response. 0.88. What is the ratio of the PPP conversion factor (LCU per international $) in Ecuador in 2008 to that in 2012?
Your answer should be very brief. 0.89. What is the ratio of the PPP conversion factor (LCU per international $) of Sri Lanka in 2008 to that in 2012?
Your answer should be very brief. 0.85. What is the ratio of the PPP conversion factor (LCU per international $) in Dominican Republic in 2008 to that in 2013?
Offer a terse response. 0.85. What is the ratio of the PPP conversion factor (LCU per international $) in Ecuador in 2008 to that in 2013?
Offer a very short reply. 0.88. What is the ratio of the PPP conversion factor (LCU per international $) of Sri Lanka in 2008 to that in 2013?
Offer a terse response. 0.8. What is the ratio of the PPP conversion factor (LCU per international $) in Dominican Republic in 2009 to that in 2010?
Your response must be concise. 0.96. What is the ratio of the PPP conversion factor (LCU per international $) in Ecuador in 2009 to that in 2010?
Offer a terse response. 0.98. What is the ratio of the PPP conversion factor (LCU per international $) in Sri Lanka in 2009 to that in 2010?
Give a very brief answer. 0.96. What is the ratio of the PPP conversion factor (LCU per international $) of Dominican Republic in 2009 to that in 2011?
Make the answer very short. 0.91. What is the ratio of the PPP conversion factor (LCU per international $) of Ecuador in 2009 to that in 2011?
Give a very brief answer. 0.97. What is the ratio of the PPP conversion factor (LCU per international $) of Sri Lanka in 2009 to that in 2011?
Your response must be concise. 0.93. What is the ratio of the PPP conversion factor (LCU per international $) of Dominican Republic in 2009 to that in 2012?
Ensure brevity in your answer.  0.89. What is the ratio of the PPP conversion factor (LCU per international $) in Ecuador in 2009 to that in 2012?
Keep it short and to the point. 0.94. What is the ratio of the PPP conversion factor (LCU per international $) in Sri Lanka in 2009 to that in 2012?
Provide a succinct answer. 0.88. What is the ratio of the PPP conversion factor (LCU per international $) in Dominican Republic in 2009 to that in 2013?
Give a very brief answer. 0.87. What is the ratio of the PPP conversion factor (LCU per international $) of Ecuador in 2009 to that in 2013?
Keep it short and to the point. 0.93. What is the ratio of the PPP conversion factor (LCU per international $) of Sri Lanka in 2009 to that in 2013?
Provide a succinct answer. 0.83. What is the ratio of the PPP conversion factor (LCU per international $) in Dominican Republic in 2010 to that in 2011?
Offer a terse response. 0.95. What is the ratio of the PPP conversion factor (LCU per international $) of Ecuador in 2010 to that in 2011?
Your answer should be compact. 0.99. What is the ratio of the PPP conversion factor (LCU per international $) in Sri Lanka in 2010 to that in 2011?
Your response must be concise. 0.97. What is the ratio of the PPP conversion factor (LCU per international $) of Dominican Republic in 2010 to that in 2012?
Keep it short and to the point. 0.94. What is the ratio of the PPP conversion factor (LCU per international $) in Ecuador in 2010 to that in 2012?
Your response must be concise. 0.96. What is the ratio of the PPP conversion factor (LCU per international $) in Sri Lanka in 2010 to that in 2012?
Make the answer very short. 0.92. What is the ratio of the PPP conversion factor (LCU per international $) in Dominican Republic in 2010 to that in 2013?
Your response must be concise. 0.91. What is the ratio of the PPP conversion factor (LCU per international $) in Ecuador in 2010 to that in 2013?
Ensure brevity in your answer.  0.95. What is the ratio of the PPP conversion factor (LCU per international $) of Sri Lanka in 2010 to that in 2013?
Give a very brief answer. 0.87. What is the ratio of the PPP conversion factor (LCU per international $) in Dominican Republic in 2011 to that in 2012?
Offer a very short reply. 0.98. What is the ratio of the PPP conversion factor (LCU per international $) in Ecuador in 2011 to that in 2012?
Ensure brevity in your answer.  0.97. What is the ratio of the PPP conversion factor (LCU per international $) in Sri Lanka in 2011 to that in 2012?
Offer a very short reply. 0.95. What is the ratio of the PPP conversion factor (LCU per international $) in Dominican Republic in 2011 to that in 2013?
Your answer should be very brief. 0.95. What is the ratio of the PPP conversion factor (LCU per international $) in Ecuador in 2011 to that in 2013?
Give a very brief answer. 0.96. What is the ratio of the PPP conversion factor (LCU per international $) of Sri Lanka in 2011 to that in 2013?
Ensure brevity in your answer.  0.9. What is the ratio of the PPP conversion factor (LCU per international $) in Dominican Republic in 2012 to that in 2013?
Ensure brevity in your answer.  0.97. What is the ratio of the PPP conversion factor (LCU per international $) in Ecuador in 2012 to that in 2013?
Provide a succinct answer. 0.99. What is the ratio of the PPP conversion factor (LCU per international $) in Sri Lanka in 2012 to that in 2013?
Make the answer very short. 0.95. What is the difference between the highest and the second highest PPP conversion factor (LCU per international $) in Dominican Republic?
Offer a terse response. 0.7. What is the difference between the highest and the second highest PPP conversion factor (LCU per international $) of Ecuador?
Make the answer very short. 0.01. What is the difference between the highest and the second highest PPP conversion factor (LCU per international $) of Sri Lanka?
Your response must be concise. 2.39. What is the difference between the highest and the lowest PPP conversion factor (LCU per international $) in Dominican Republic?
Your response must be concise. 4.93. What is the difference between the highest and the lowest PPP conversion factor (LCU per international $) in Ecuador?
Keep it short and to the point. 0.09. What is the difference between the highest and the lowest PPP conversion factor (LCU per international $) of Sri Lanka?
Your answer should be compact. 18.58. 